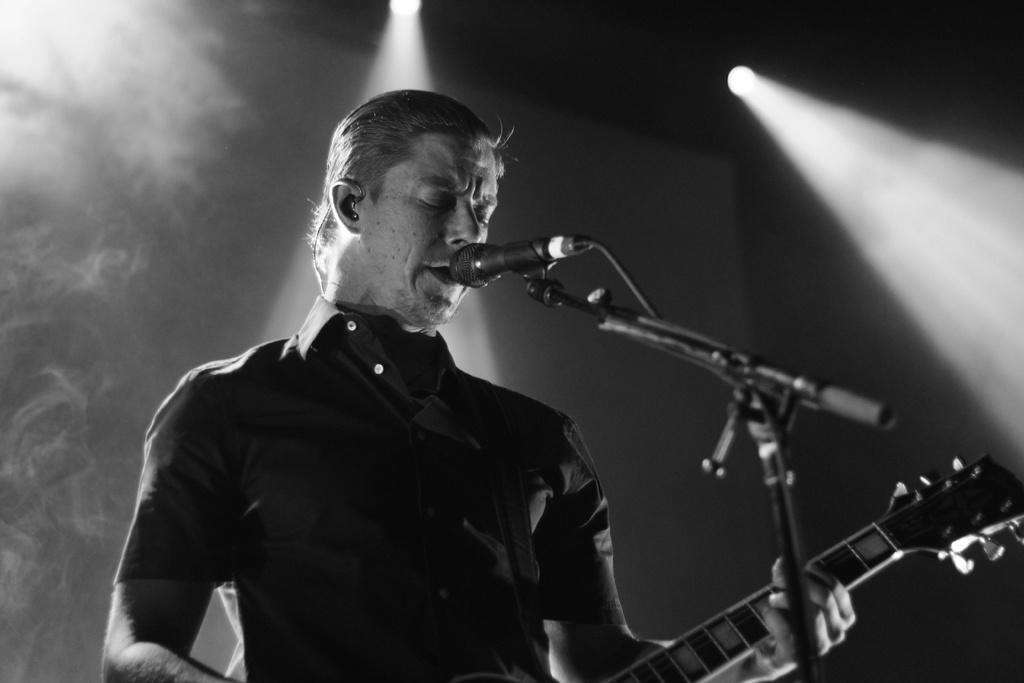Who is the main subject in the image? There is a man in the image. What is the man holding in the image? The man is holding a guitar. What object is in front of the man? There is a microphone (mic) in front of the man. What color is the stocking on the man's throat in the image? There is no stocking visible on the man's throat in the image. What type of tank is present in the image? There is no tank present in the image. 